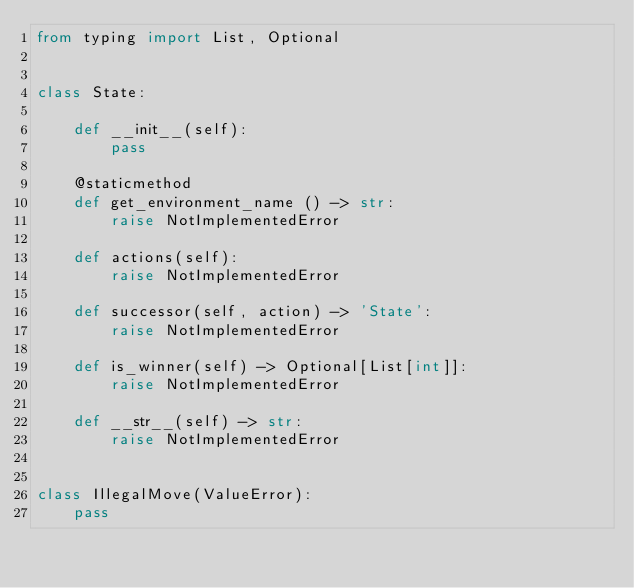<code> <loc_0><loc_0><loc_500><loc_500><_Python_>from typing import List, Optional


class State:

    def __init__(self):
        pass

    @staticmethod
    def get_environment_name () -> str:
        raise NotImplementedError

    def actions(self):
        raise NotImplementedError

    def successor(self, action) -> 'State':
        raise NotImplementedError

    def is_winner(self) -> Optional[List[int]]:
        raise NotImplementedError

    def __str__(self) -> str:
        raise NotImplementedError


class IllegalMove(ValueError):
    pass</code> 